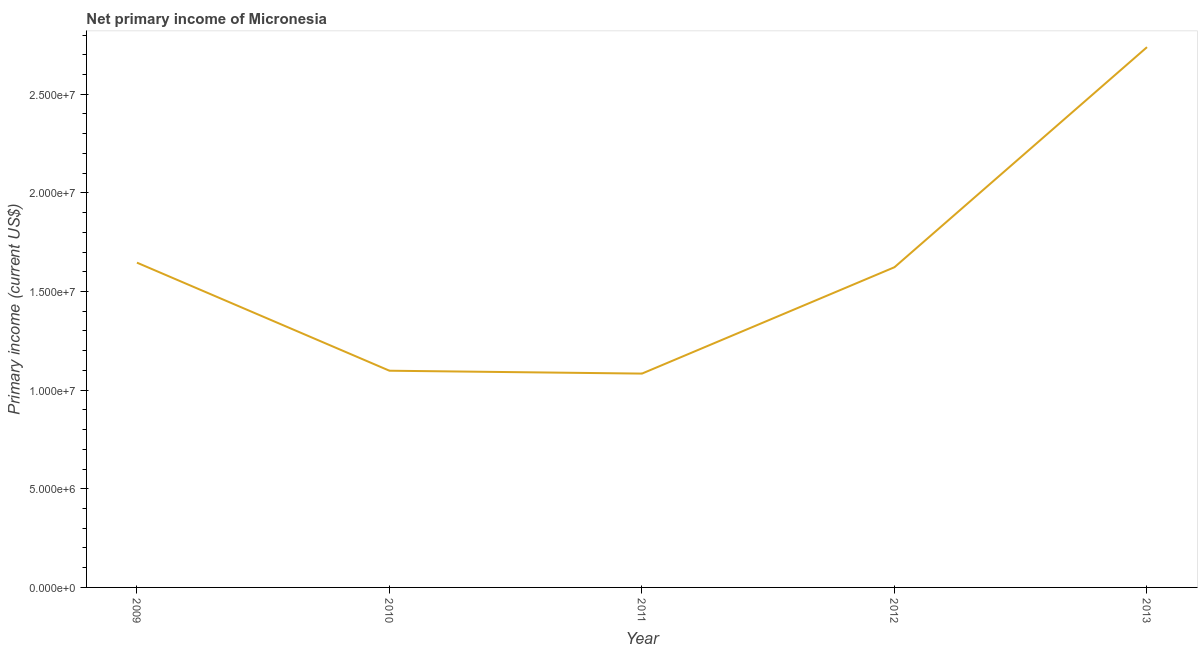What is the amount of primary income in 2013?
Give a very brief answer. 2.74e+07. Across all years, what is the maximum amount of primary income?
Your answer should be very brief. 2.74e+07. Across all years, what is the minimum amount of primary income?
Your response must be concise. 1.08e+07. In which year was the amount of primary income maximum?
Your response must be concise. 2013. In which year was the amount of primary income minimum?
Offer a very short reply. 2011. What is the sum of the amount of primary income?
Make the answer very short. 8.19e+07. What is the difference between the amount of primary income in 2009 and 2010?
Provide a short and direct response. 5.48e+06. What is the average amount of primary income per year?
Offer a very short reply. 1.64e+07. What is the median amount of primary income?
Make the answer very short. 1.62e+07. In how many years, is the amount of primary income greater than 23000000 US$?
Your answer should be compact. 1. Do a majority of the years between 2010 and 2011 (inclusive) have amount of primary income greater than 13000000 US$?
Make the answer very short. No. What is the ratio of the amount of primary income in 2009 to that in 2012?
Make the answer very short. 1.01. Is the difference between the amount of primary income in 2009 and 2013 greater than the difference between any two years?
Your answer should be very brief. No. What is the difference between the highest and the second highest amount of primary income?
Your answer should be very brief. 1.09e+07. What is the difference between the highest and the lowest amount of primary income?
Your response must be concise. 1.65e+07. Does the amount of primary income monotonically increase over the years?
Make the answer very short. No. How many lines are there?
Make the answer very short. 1. What is the difference between two consecutive major ticks on the Y-axis?
Make the answer very short. 5.00e+06. Does the graph contain any zero values?
Provide a succinct answer. No. Does the graph contain grids?
Offer a terse response. No. What is the title of the graph?
Your response must be concise. Net primary income of Micronesia. What is the label or title of the X-axis?
Provide a short and direct response. Year. What is the label or title of the Y-axis?
Your response must be concise. Primary income (current US$). What is the Primary income (current US$) in 2009?
Offer a terse response. 1.65e+07. What is the Primary income (current US$) in 2010?
Your answer should be compact. 1.10e+07. What is the Primary income (current US$) of 2011?
Your answer should be compact. 1.08e+07. What is the Primary income (current US$) in 2012?
Offer a terse response. 1.62e+07. What is the Primary income (current US$) in 2013?
Offer a very short reply. 2.74e+07. What is the difference between the Primary income (current US$) in 2009 and 2010?
Provide a succinct answer. 5.48e+06. What is the difference between the Primary income (current US$) in 2009 and 2011?
Your response must be concise. 5.62e+06. What is the difference between the Primary income (current US$) in 2009 and 2012?
Give a very brief answer. 2.32e+05. What is the difference between the Primary income (current US$) in 2009 and 2013?
Your response must be concise. -1.09e+07. What is the difference between the Primary income (current US$) in 2010 and 2011?
Your answer should be compact. 1.46e+05. What is the difference between the Primary income (current US$) in 2010 and 2012?
Make the answer very short. -5.25e+06. What is the difference between the Primary income (current US$) in 2010 and 2013?
Give a very brief answer. -1.64e+07. What is the difference between the Primary income (current US$) in 2011 and 2012?
Keep it short and to the point. -5.39e+06. What is the difference between the Primary income (current US$) in 2011 and 2013?
Provide a short and direct response. -1.65e+07. What is the difference between the Primary income (current US$) in 2012 and 2013?
Provide a succinct answer. -1.12e+07. What is the ratio of the Primary income (current US$) in 2009 to that in 2010?
Keep it short and to the point. 1.5. What is the ratio of the Primary income (current US$) in 2009 to that in 2011?
Your answer should be very brief. 1.52. What is the ratio of the Primary income (current US$) in 2009 to that in 2013?
Your answer should be compact. 0.6. What is the ratio of the Primary income (current US$) in 2010 to that in 2012?
Your answer should be very brief. 0.68. What is the ratio of the Primary income (current US$) in 2010 to that in 2013?
Ensure brevity in your answer.  0.4. What is the ratio of the Primary income (current US$) in 2011 to that in 2012?
Offer a very short reply. 0.67. What is the ratio of the Primary income (current US$) in 2011 to that in 2013?
Provide a short and direct response. 0.4. What is the ratio of the Primary income (current US$) in 2012 to that in 2013?
Offer a terse response. 0.59. 